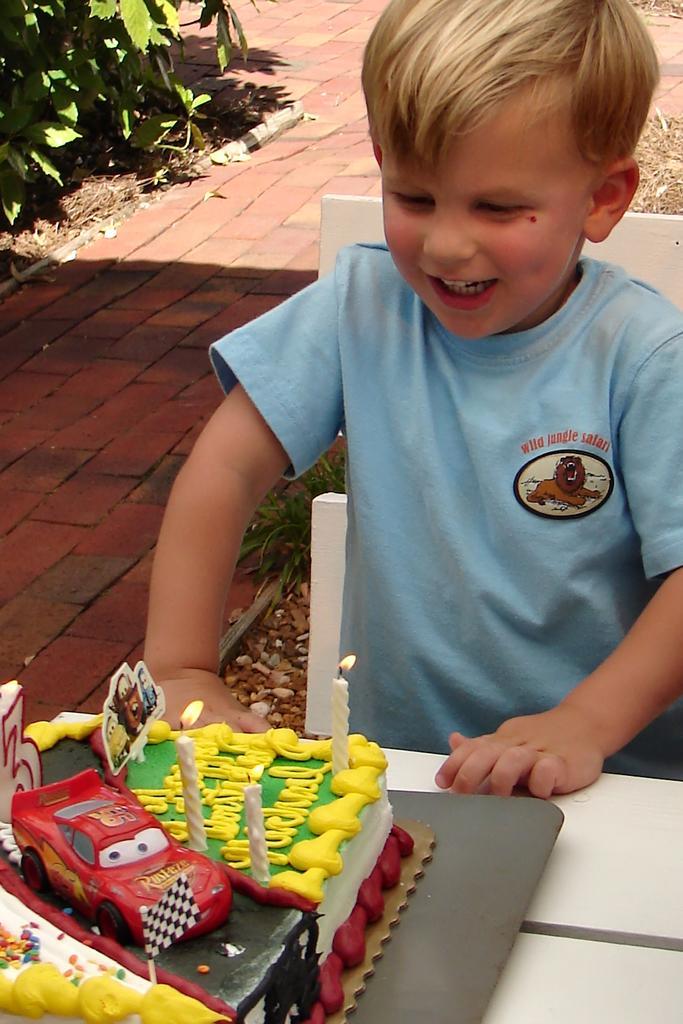Could you give a brief overview of what you see in this image? In this picture there is a boy sitting and smiling. There is a cake on the table, on the cake there is a picture of a car, flag and there is a text and there are candles. At the back there plants, stones and tiles. 